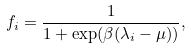<formula> <loc_0><loc_0><loc_500><loc_500>f _ { i } = \frac { 1 } { 1 + \exp ( \beta ( \lambda _ { i } - \mu ) ) } ,</formula> 